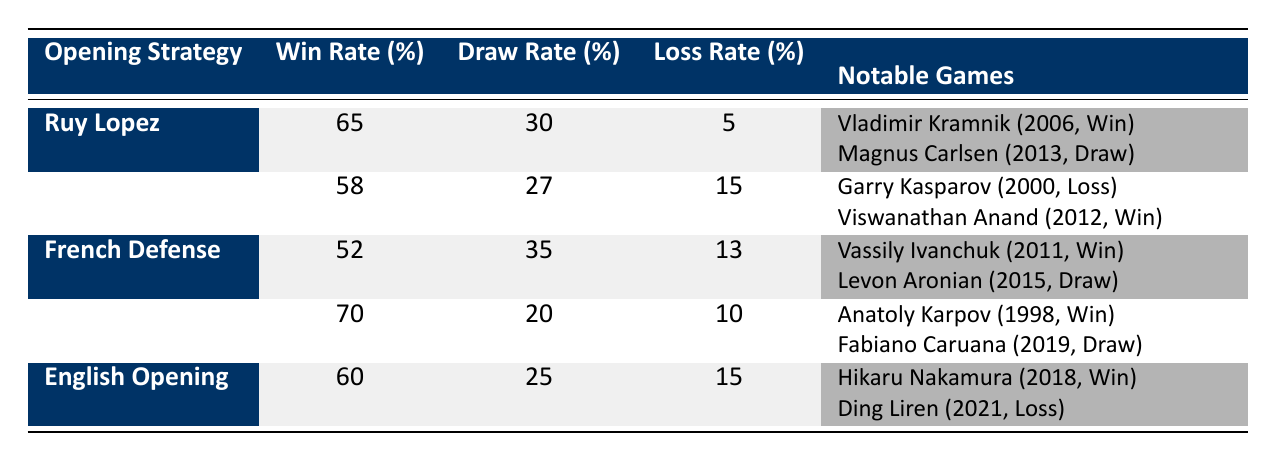What is the win rate of the Queen's Gambit? The win rate of the Queen's Gambit can be found in the table under the "Win Rate (%)" column next to the Queen's Gambit row. It shows a win rate of 70%.
Answer: 70% Which opening strategy has the highest draw rate? By comparing the draw rates in the table, the Queen's Gambit has a draw rate of 20%, which is lower than the draw rates of the French Defense (35%) and Sicilian Defense (27%). Therefore, the French Defense has the highest draw rate at 35%.
Answer: 35% How many notable games did you win using the Ruy Lopez? The Ruy Lopez has two notable games listed; one against Vladimir Kramnik in 2006 where the result was a win. Therefore, you won 1 notable game using Ruy Lopez.
Answer: 1 What is the total loss rate for all opening strategies? To find the total loss rate, we add the loss rates from all strategies: 5 + 15 + 13 + 10 + 15 = 58. The total loss rate across all openings is 58%.
Answer: 58% Is it true that the Sicilian Defense has a higher win rate than the French Defense? The Sicilian Defense has a win rate of 58%, while the French Defense has a win rate of 52%. Since 58 is greater than 52, the statement is true.
Answer: Yes What is the average win rate of all opening strategies? The win rates are 65, 58, 52, 70, and 60. To get the average, sum these values (65 + 58 + 52 + 70 + 60 = 305) and divide by the number of strategies (5): 305 / 5 = 61. The average win rate is 61%.
Answer: 61% Which opponent did you lose against using the Sicilian Defense? The table indicates a notable game with Garry Kasparov in the year 2000 with a result of Loss. Thus, the opponent lost against was Garry Kasparov.
Answer: Garry Kasparov How many opening strategies have a loss rate of 15% or higher? The strategies with loss rates of 15% or higher are Sicilian Defense (15%), English Opening (15%), and these two only. Thus, there are 2 such strategies.
Answer: 2 Which opening strategy had the most wins against notable opponents? By reviewing the notable games listed, Ruy Lopez (1 win) and Queen's Gambit (1 win) both feature one win, though Queen's Gambit had fewer total strategies and notable matchups. Therefore, both get equal consideration, but overall, no strategy here shows more wins than notable loses.
Answer: Ruy Lopez and Queen's Gambit 